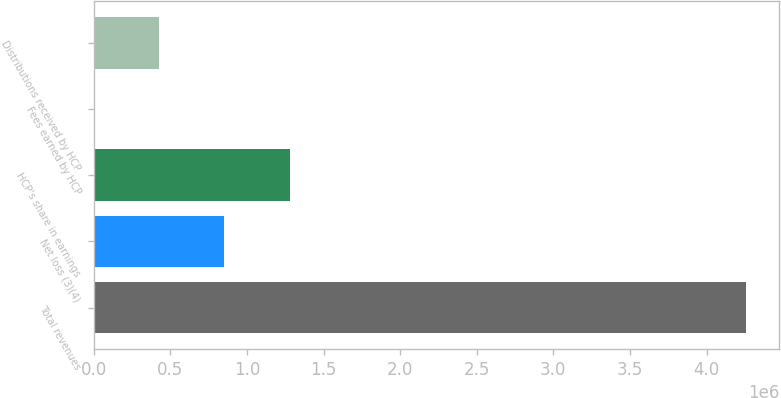Convert chart to OTSL. <chart><loc_0><loc_0><loc_500><loc_500><bar_chart><fcel>Total revenues<fcel>Net loss (3)(4)<fcel>HCP's share in earnings<fcel>Fees earned by HCP<fcel>Distributions received by HCP<nl><fcel>4.26032e+06<fcel>853580<fcel>1.27942e+06<fcel>1895<fcel>427737<nl></chart> 